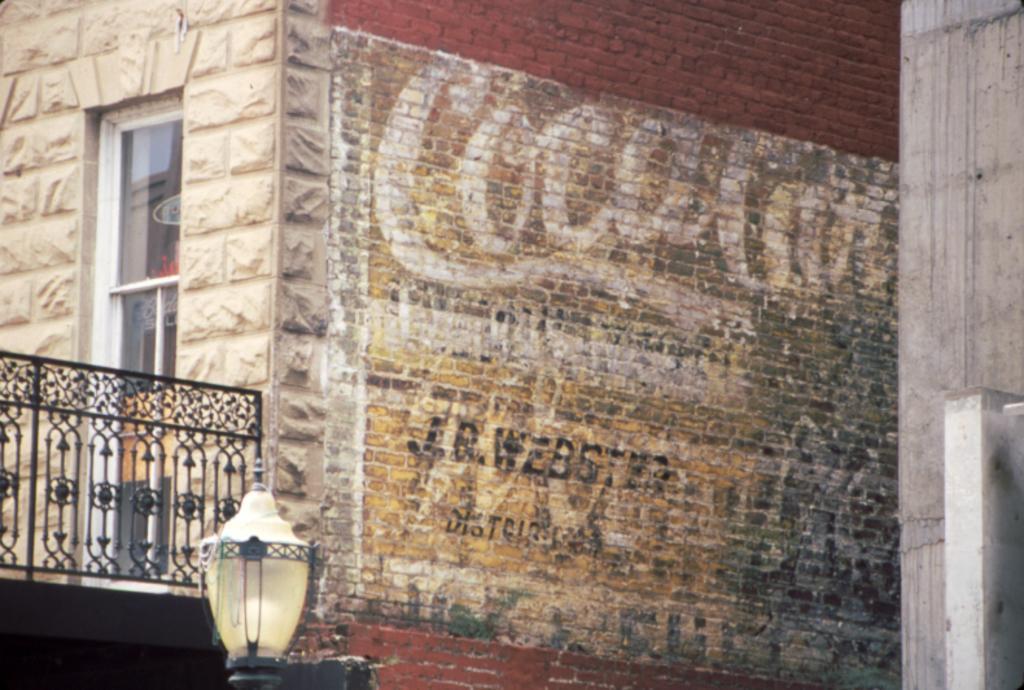Can you describe this image briefly? In this image I can see building walls with some bricks and stones I can see a window and a balcony. On the right hand side I can see a pillar. In the center of the image the brick wall is painted with some text. At the bottom of the image towards the left hand side, I can see a pole light. 